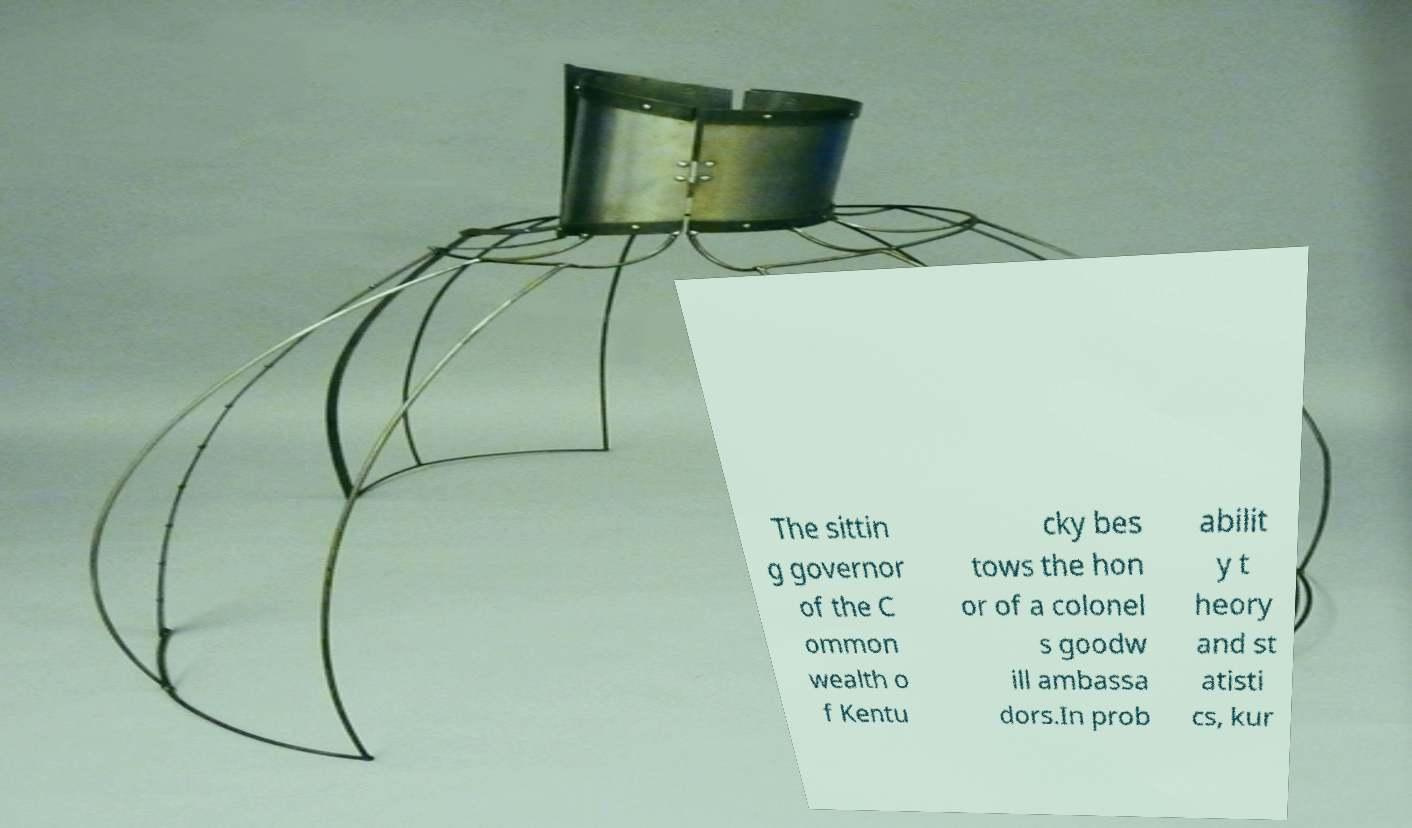Could you assist in decoding the text presented in this image and type it out clearly? The sittin g governor of the C ommon wealth o f Kentu cky bes tows the hon or of a colonel s goodw ill ambassa dors.In prob abilit y t heory and st atisti cs, kur 